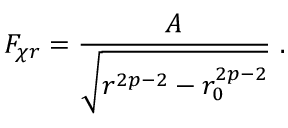Convert formula to latex. <formula><loc_0><loc_0><loc_500><loc_500>F _ { \chi r } = \frac { A } { \sqrt { r ^ { 2 p - 2 } - r _ { 0 } ^ { 2 p - 2 } } } \ .</formula> 